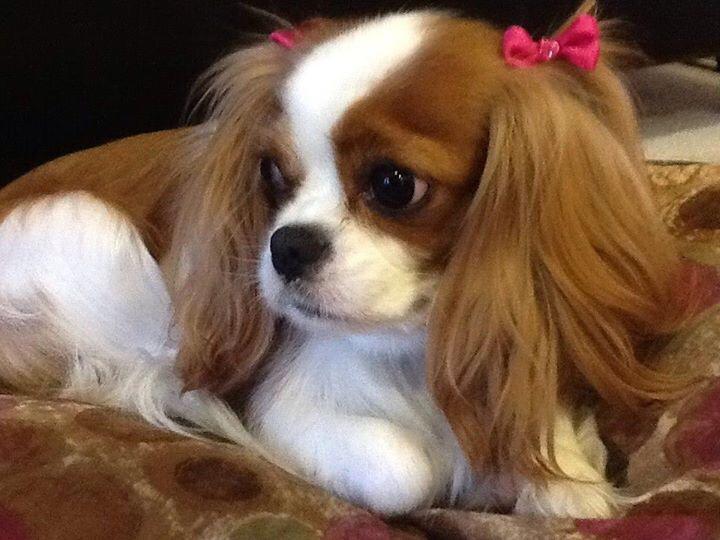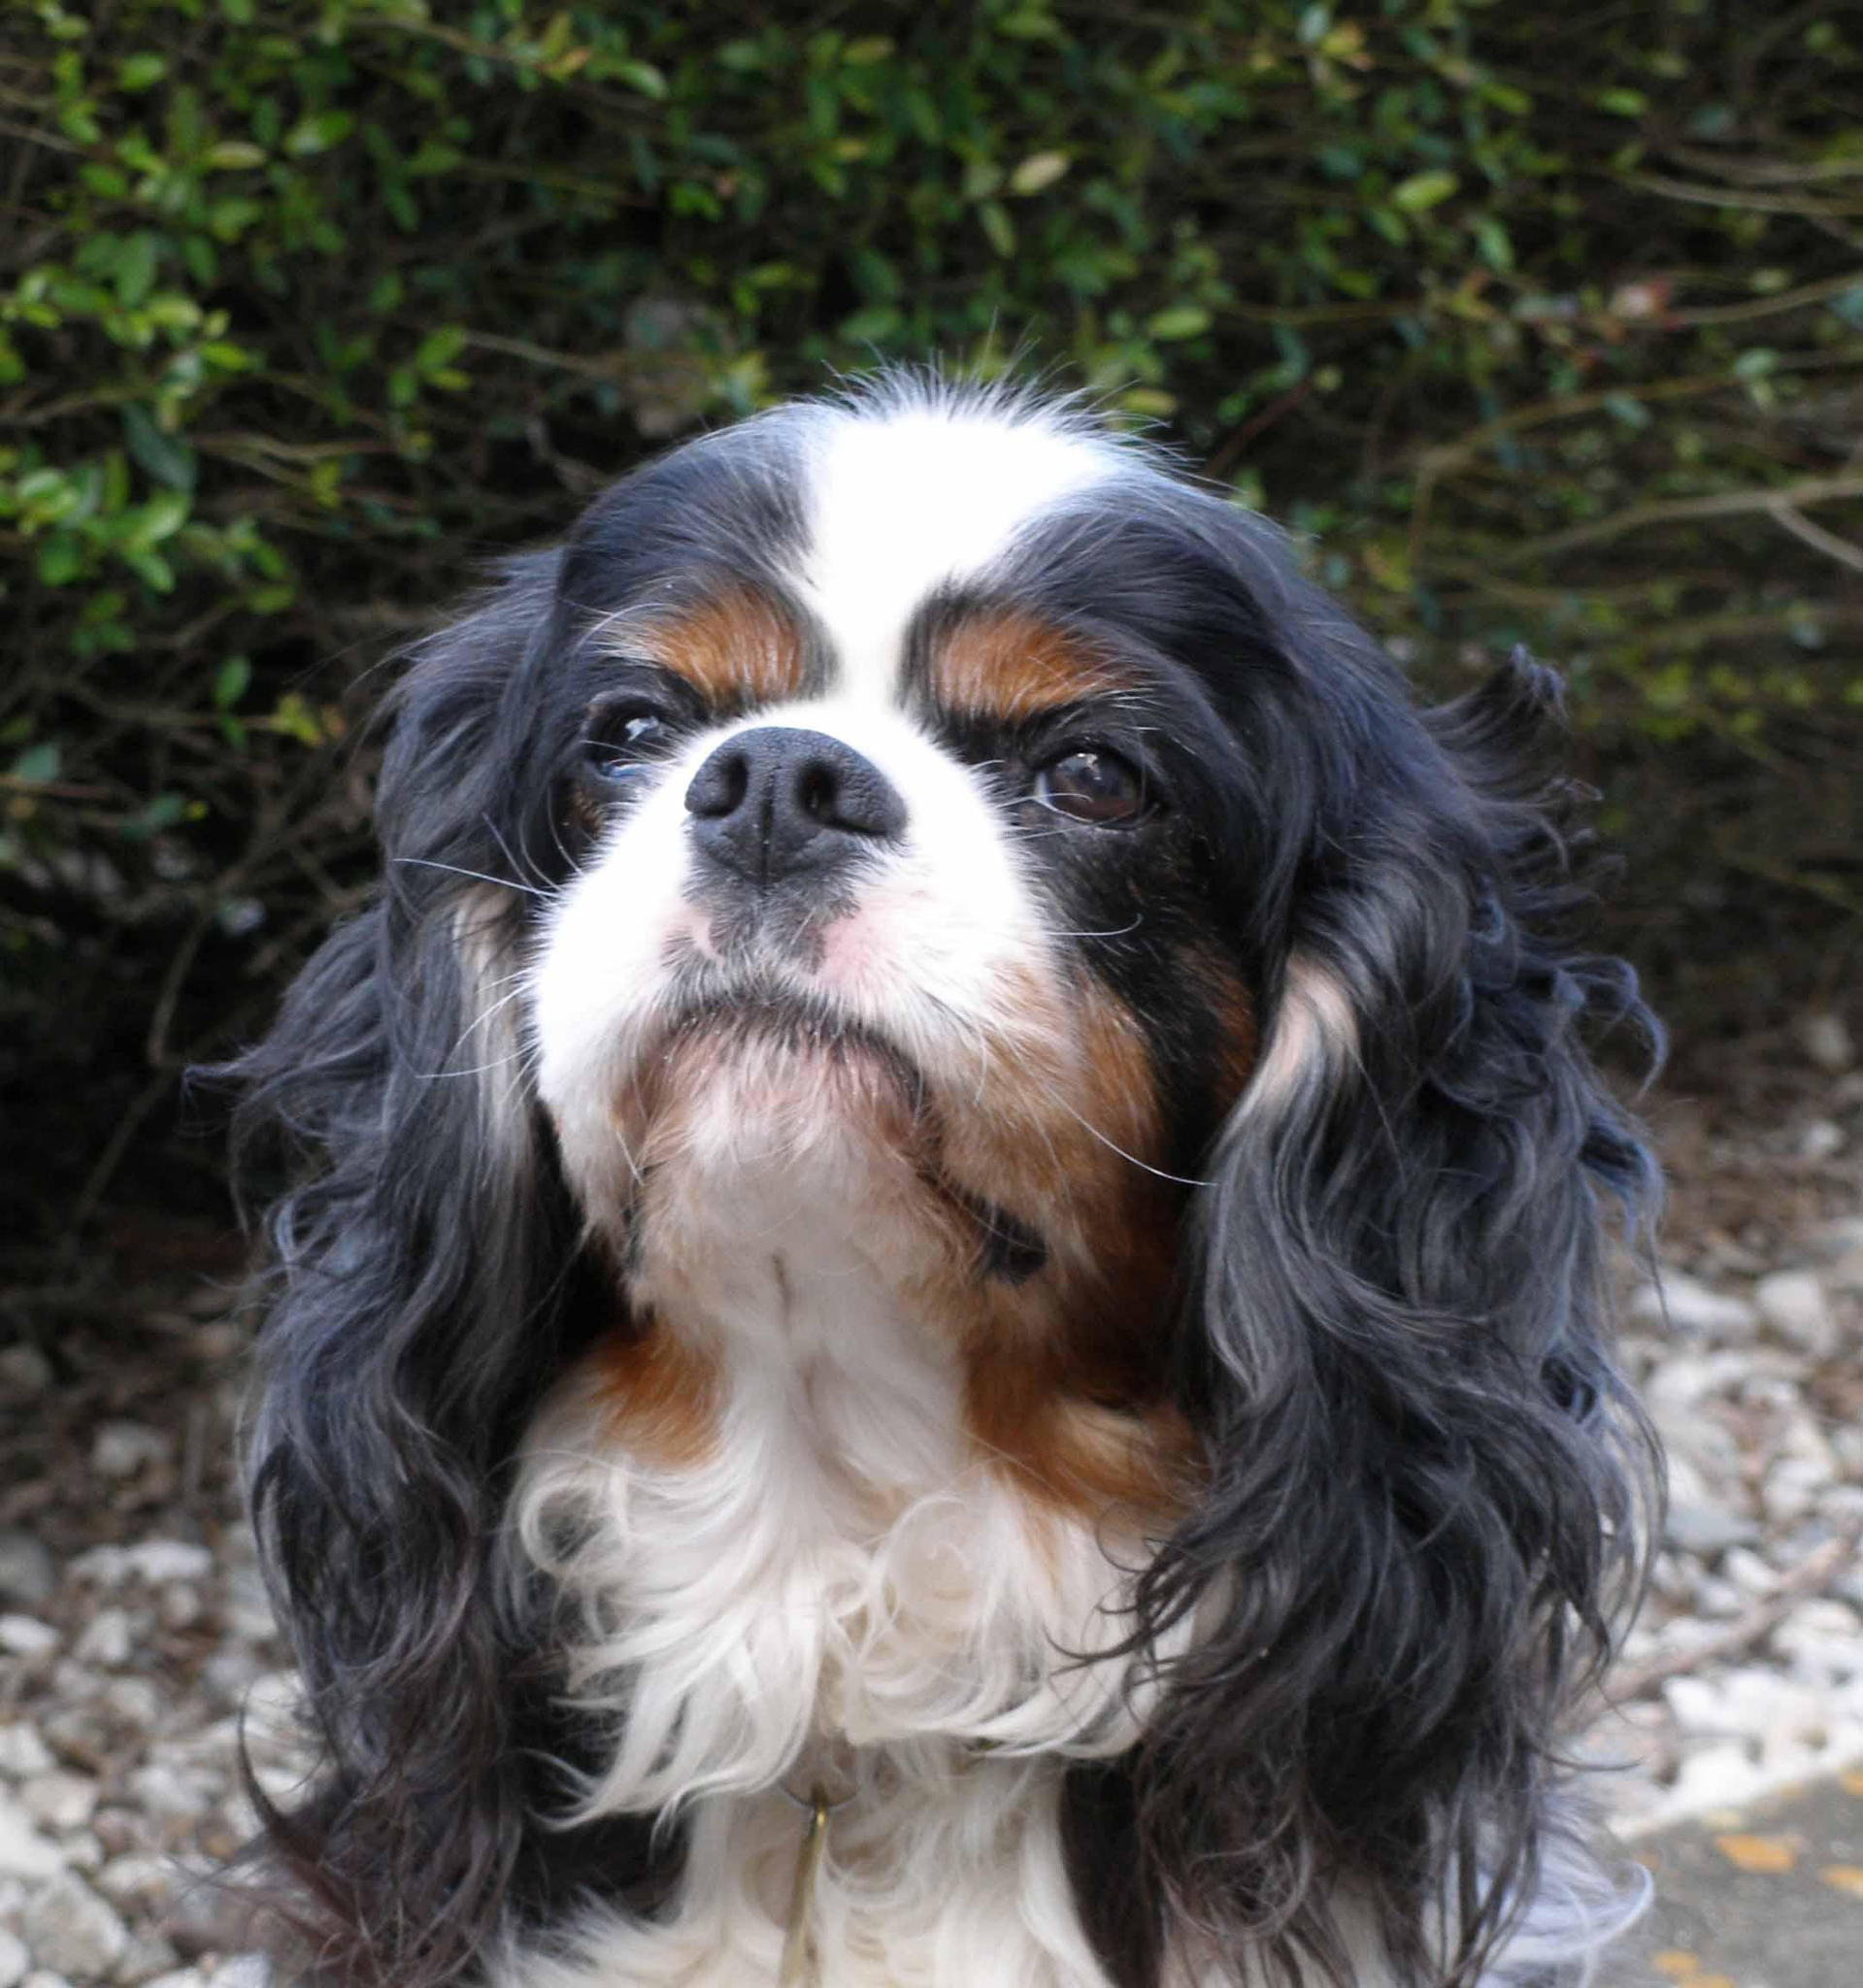The first image is the image on the left, the second image is the image on the right. Assess this claim about the two images: "An image shows one tan-and-white spaniel reclining directly on green grass.". Correct or not? Answer yes or no. No. The first image is the image on the left, the second image is the image on the right. Considering the images on both sides, is "One of the images contain one dog lying on grass." valid? Answer yes or no. No. 